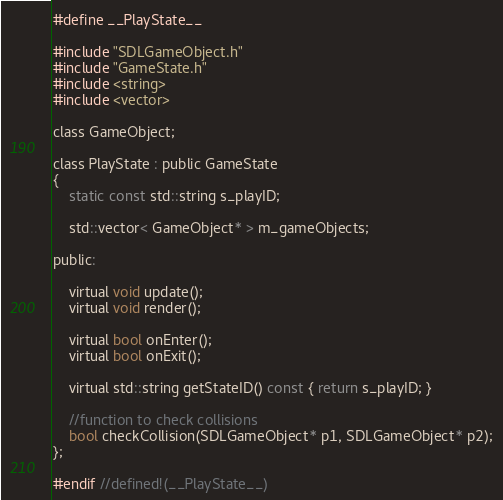<code> <loc_0><loc_0><loc_500><loc_500><_C_>#define __PlayState__

#include "SDLGameObject.h"
#include "GameState.h"
#include <string>
#include <vector>

class GameObject;

class PlayState : public GameState
{
	static const std::string s_playID;

	std::vector< GameObject* > m_gameObjects;

public:

	virtual void update();
	virtual void render();

	virtual bool onEnter();
	virtual bool onExit();

	virtual std::string getStateID() const { return s_playID; }

	//function to check collisions
	bool checkCollision(SDLGameObject* p1, SDLGameObject* p2);
};

#endif //defined!(__PlayState__)</code> 